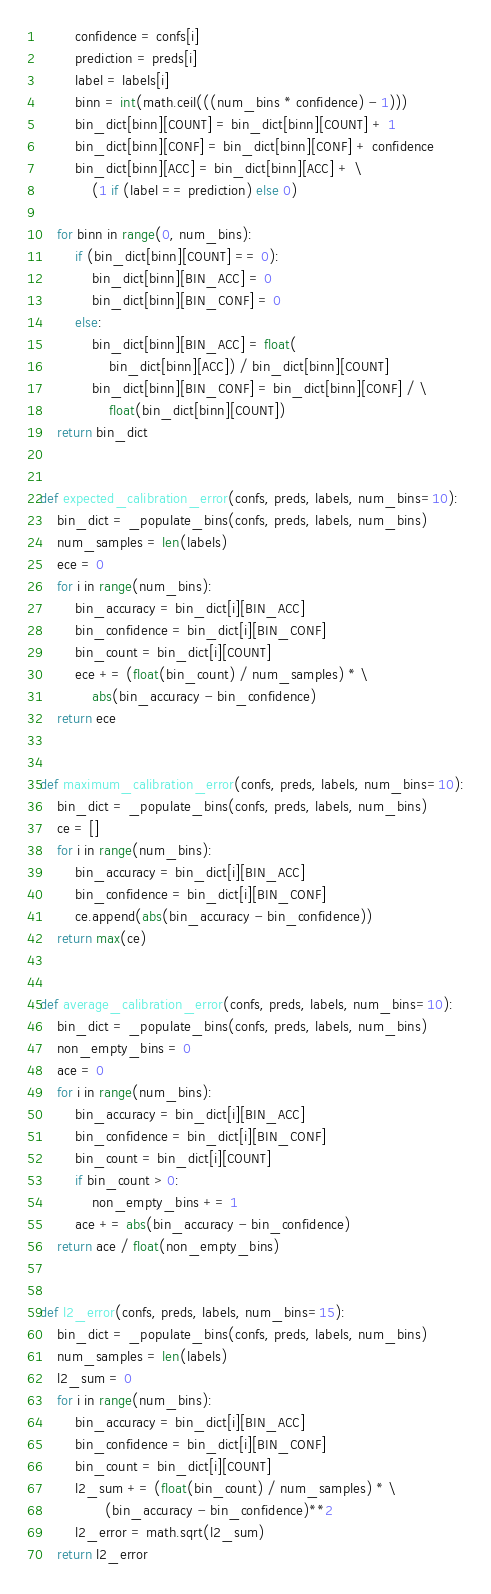Convert code to text. <code><loc_0><loc_0><loc_500><loc_500><_Python_>        confidence = confs[i]
        prediction = preds[i]
        label = labels[i]
        binn = int(math.ceil(((num_bins * confidence) - 1)))
        bin_dict[binn][COUNT] = bin_dict[binn][COUNT] + 1
        bin_dict[binn][CONF] = bin_dict[binn][CONF] + confidence
        bin_dict[binn][ACC] = bin_dict[binn][ACC] + \
            (1 if (label == prediction) else 0)

    for binn in range(0, num_bins):
        if (bin_dict[binn][COUNT] == 0):
            bin_dict[binn][BIN_ACC] = 0
            bin_dict[binn][BIN_CONF] = 0
        else:
            bin_dict[binn][BIN_ACC] = float(
                bin_dict[binn][ACC]) / bin_dict[binn][COUNT]
            bin_dict[binn][BIN_CONF] = bin_dict[binn][CONF] / \
                float(bin_dict[binn][COUNT])
    return bin_dict


def expected_calibration_error(confs, preds, labels, num_bins=10):
    bin_dict = _populate_bins(confs, preds, labels, num_bins)
    num_samples = len(labels)
    ece = 0
    for i in range(num_bins):
        bin_accuracy = bin_dict[i][BIN_ACC]
        bin_confidence = bin_dict[i][BIN_CONF]
        bin_count = bin_dict[i][COUNT]
        ece += (float(bin_count) / num_samples) * \
            abs(bin_accuracy - bin_confidence)
    return ece


def maximum_calibration_error(confs, preds, labels, num_bins=10):
    bin_dict = _populate_bins(confs, preds, labels, num_bins)
    ce = []
    for i in range(num_bins):
        bin_accuracy = bin_dict[i][BIN_ACC]
        bin_confidence = bin_dict[i][BIN_CONF]
        ce.append(abs(bin_accuracy - bin_confidence))
    return max(ce)


def average_calibration_error(confs, preds, labels, num_bins=10):
    bin_dict = _populate_bins(confs, preds, labels, num_bins)
    non_empty_bins = 0
    ace = 0
    for i in range(num_bins):
        bin_accuracy = bin_dict[i][BIN_ACC]
        bin_confidence = bin_dict[i][BIN_CONF]
        bin_count = bin_dict[i][COUNT]
        if bin_count > 0:
            non_empty_bins += 1
        ace += abs(bin_accuracy - bin_confidence)
    return ace / float(non_empty_bins)


def l2_error(confs, preds, labels, num_bins=15):
    bin_dict = _populate_bins(confs, preds, labels, num_bins)
    num_samples = len(labels)
    l2_sum = 0
    for i in range(num_bins):
        bin_accuracy = bin_dict[i][BIN_ACC]
        bin_confidence = bin_dict[i][BIN_CONF]
        bin_count = bin_dict[i][COUNT]
        l2_sum += (float(bin_count) / num_samples) * \
               (bin_accuracy - bin_confidence)**2
        l2_error = math.sqrt(l2_sum)
    return l2_error

</code> 